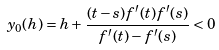<formula> <loc_0><loc_0><loc_500><loc_500>y _ { 0 } ( h ) = h + \frac { ( t - s ) f ^ { \prime } ( t ) f ^ { \prime } ( s ) } { f ^ { \prime } ( t ) - f ^ { \prime } ( s ) } < 0</formula> 